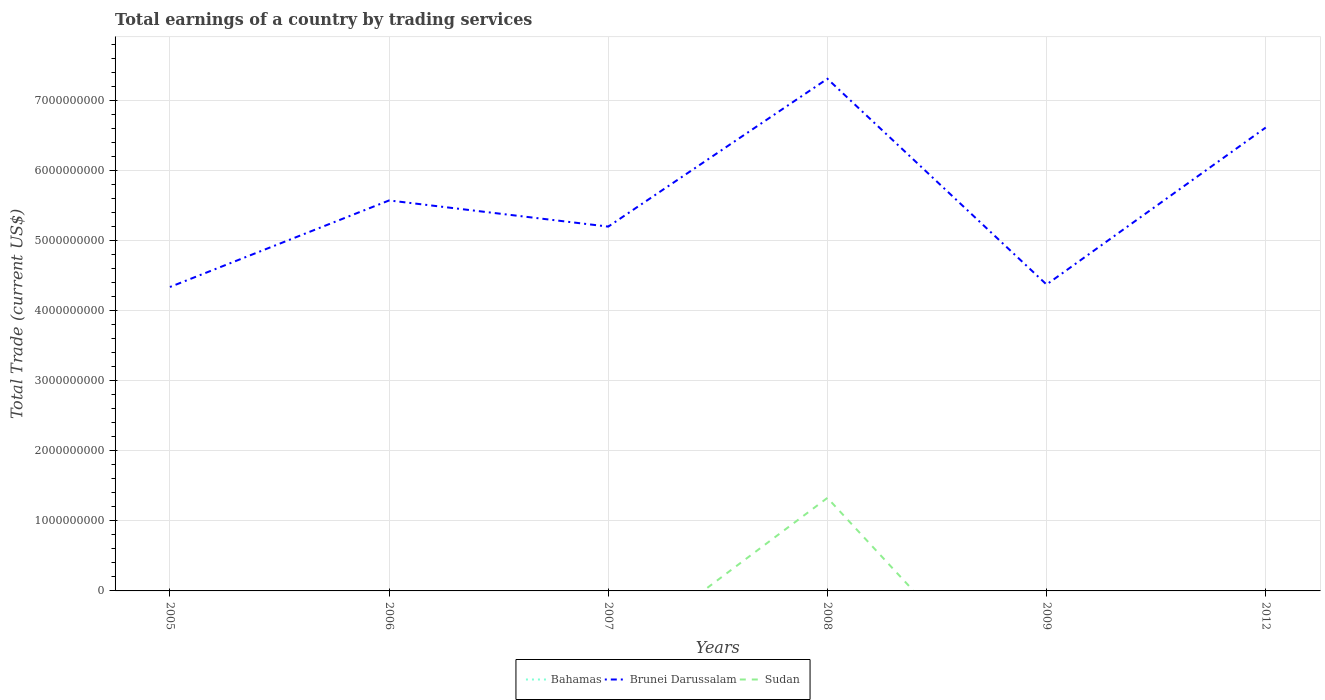How many different coloured lines are there?
Give a very brief answer. 2. Across all years, what is the maximum total earnings in Bahamas?
Provide a short and direct response. 0. What is the difference between the highest and the second highest total earnings in Sudan?
Offer a terse response. 1.33e+09. Is the total earnings in Sudan strictly greater than the total earnings in Brunei Darussalam over the years?
Provide a short and direct response. Yes. Does the graph contain any zero values?
Ensure brevity in your answer.  Yes. Does the graph contain grids?
Your answer should be very brief. Yes. How are the legend labels stacked?
Your response must be concise. Horizontal. What is the title of the graph?
Ensure brevity in your answer.  Total earnings of a country by trading services. Does "French Polynesia" appear as one of the legend labels in the graph?
Ensure brevity in your answer.  No. What is the label or title of the Y-axis?
Give a very brief answer. Total Trade (current US$). What is the Total Trade (current US$) in Bahamas in 2005?
Ensure brevity in your answer.  0. What is the Total Trade (current US$) in Brunei Darussalam in 2005?
Offer a very short reply. 4.34e+09. What is the Total Trade (current US$) in Sudan in 2005?
Provide a short and direct response. 0. What is the Total Trade (current US$) of Bahamas in 2006?
Your response must be concise. 0. What is the Total Trade (current US$) in Brunei Darussalam in 2006?
Provide a succinct answer. 5.57e+09. What is the Total Trade (current US$) in Brunei Darussalam in 2007?
Offer a terse response. 5.20e+09. What is the Total Trade (current US$) in Bahamas in 2008?
Keep it short and to the point. 0. What is the Total Trade (current US$) of Brunei Darussalam in 2008?
Provide a short and direct response. 7.30e+09. What is the Total Trade (current US$) in Sudan in 2008?
Your answer should be compact. 1.33e+09. What is the Total Trade (current US$) of Brunei Darussalam in 2009?
Give a very brief answer. 4.37e+09. What is the Total Trade (current US$) of Brunei Darussalam in 2012?
Offer a terse response. 6.61e+09. Across all years, what is the maximum Total Trade (current US$) in Brunei Darussalam?
Provide a succinct answer. 7.30e+09. Across all years, what is the maximum Total Trade (current US$) of Sudan?
Your answer should be very brief. 1.33e+09. Across all years, what is the minimum Total Trade (current US$) in Brunei Darussalam?
Your response must be concise. 4.34e+09. What is the total Total Trade (current US$) in Brunei Darussalam in the graph?
Make the answer very short. 3.34e+1. What is the total Total Trade (current US$) of Sudan in the graph?
Your answer should be very brief. 1.33e+09. What is the difference between the Total Trade (current US$) in Brunei Darussalam in 2005 and that in 2006?
Provide a short and direct response. -1.23e+09. What is the difference between the Total Trade (current US$) of Brunei Darussalam in 2005 and that in 2007?
Provide a succinct answer. -8.61e+08. What is the difference between the Total Trade (current US$) of Brunei Darussalam in 2005 and that in 2008?
Give a very brief answer. -2.97e+09. What is the difference between the Total Trade (current US$) of Brunei Darussalam in 2005 and that in 2009?
Your answer should be very brief. -3.50e+07. What is the difference between the Total Trade (current US$) of Brunei Darussalam in 2005 and that in 2012?
Offer a very short reply. -2.27e+09. What is the difference between the Total Trade (current US$) in Brunei Darussalam in 2006 and that in 2007?
Offer a very short reply. 3.73e+08. What is the difference between the Total Trade (current US$) in Brunei Darussalam in 2006 and that in 2008?
Ensure brevity in your answer.  -1.74e+09. What is the difference between the Total Trade (current US$) of Brunei Darussalam in 2006 and that in 2009?
Your response must be concise. 1.20e+09. What is the difference between the Total Trade (current US$) in Brunei Darussalam in 2006 and that in 2012?
Offer a terse response. -1.04e+09. What is the difference between the Total Trade (current US$) in Brunei Darussalam in 2007 and that in 2008?
Offer a terse response. -2.11e+09. What is the difference between the Total Trade (current US$) of Brunei Darussalam in 2007 and that in 2009?
Provide a short and direct response. 8.26e+08. What is the difference between the Total Trade (current US$) of Brunei Darussalam in 2007 and that in 2012?
Your answer should be very brief. -1.41e+09. What is the difference between the Total Trade (current US$) in Brunei Darussalam in 2008 and that in 2009?
Make the answer very short. 2.93e+09. What is the difference between the Total Trade (current US$) of Brunei Darussalam in 2008 and that in 2012?
Keep it short and to the point. 6.96e+08. What is the difference between the Total Trade (current US$) of Brunei Darussalam in 2009 and that in 2012?
Make the answer very short. -2.24e+09. What is the difference between the Total Trade (current US$) in Brunei Darussalam in 2005 and the Total Trade (current US$) in Sudan in 2008?
Provide a succinct answer. 3.01e+09. What is the difference between the Total Trade (current US$) of Brunei Darussalam in 2006 and the Total Trade (current US$) of Sudan in 2008?
Ensure brevity in your answer.  4.24e+09. What is the difference between the Total Trade (current US$) of Brunei Darussalam in 2007 and the Total Trade (current US$) of Sudan in 2008?
Your response must be concise. 3.87e+09. What is the average Total Trade (current US$) in Brunei Darussalam per year?
Provide a succinct answer. 5.56e+09. What is the average Total Trade (current US$) in Sudan per year?
Your answer should be compact. 2.21e+08. In the year 2008, what is the difference between the Total Trade (current US$) of Brunei Darussalam and Total Trade (current US$) of Sudan?
Ensure brevity in your answer.  5.98e+09. What is the ratio of the Total Trade (current US$) in Brunei Darussalam in 2005 to that in 2006?
Make the answer very short. 0.78. What is the ratio of the Total Trade (current US$) in Brunei Darussalam in 2005 to that in 2007?
Keep it short and to the point. 0.83. What is the ratio of the Total Trade (current US$) of Brunei Darussalam in 2005 to that in 2008?
Your answer should be compact. 0.59. What is the ratio of the Total Trade (current US$) of Brunei Darussalam in 2005 to that in 2009?
Give a very brief answer. 0.99. What is the ratio of the Total Trade (current US$) of Brunei Darussalam in 2005 to that in 2012?
Offer a very short reply. 0.66. What is the ratio of the Total Trade (current US$) of Brunei Darussalam in 2006 to that in 2007?
Offer a terse response. 1.07. What is the ratio of the Total Trade (current US$) in Brunei Darussalam in 2006 to that in 2008?
Keep it short and to the point. 0.76. What is the ratio of the Total Trade (current US$) in Brunei Darussalam in 2006 to that in 2009?
Your response must be concise. 1.27. What is the ratio of the Total Trade (current US$) in Brunei Darussalam in 2006 to that in 2012?
Give a very brief answer. 0.84. What is the ratio of the Total Trade (current US$) of Brunei Darussalam in 2007 to that in 2008?
Your response must be concise. 0.71. What is the ratio of the Total Trade (current US$) of Brunei Darussalam in 2007 to that in 2009?
Your answer should be compact. 1.19. What is the ratio of the Total Trade (current US$) in Brunei Darussalam in 2007 to that in 2012?
Keep it short and to the point. 0.79. What is the ratio of the Total Trade (current US$) of Brunei Darussalam in 2008 to that in 2009?
Your answer should be compact. 1.67. What is the ratio of the Total Trade (current US$) of Brunei Darussalam in 2008 to that in 2012?
Your answer should be compact. 1.11. What is the ratio of the Total Trade (current US$) of Brunei Darussalam in 2009 to that in 2012?
Provide a short and direct response. 0.66. What is the difference between the highest and the second highest Total Trade (current US$) in Brunei Darussalam?
Provide a short and direct response. 6.96e+08. What is the difference between the highest and the lowest Total Trade (current US$) in Brunei Darussalam?
Your response must be concise. 2.97e+09. What is the difference between the highest and the lowest Total Trade (current US$) in Sudan?
Ensure brevity in your answer.  1.33e+09. 